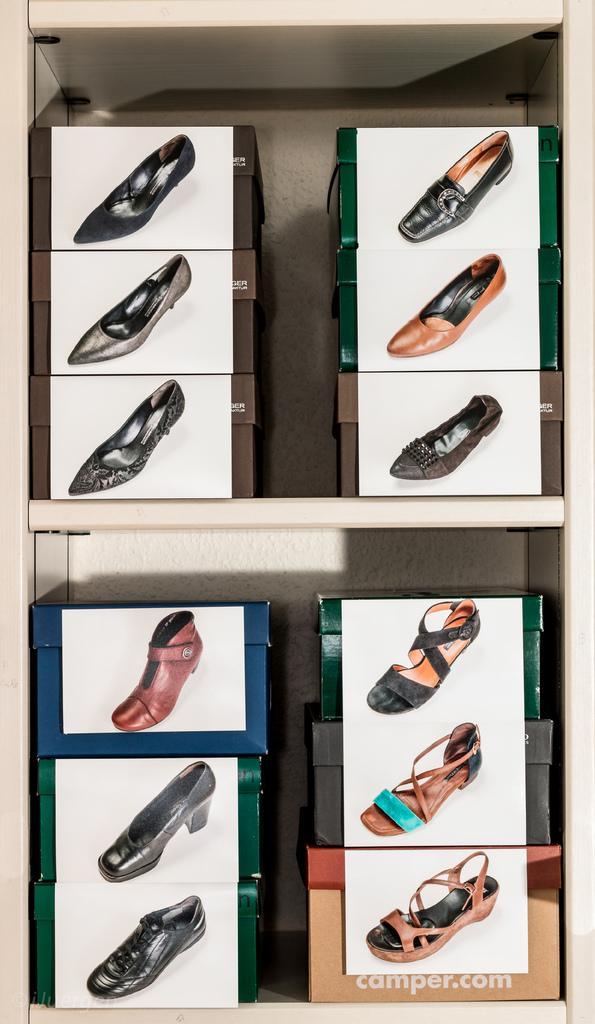Please provide a concise description of this image. In the image there are racks with shoe boxes on it with shoe pictures above it. 